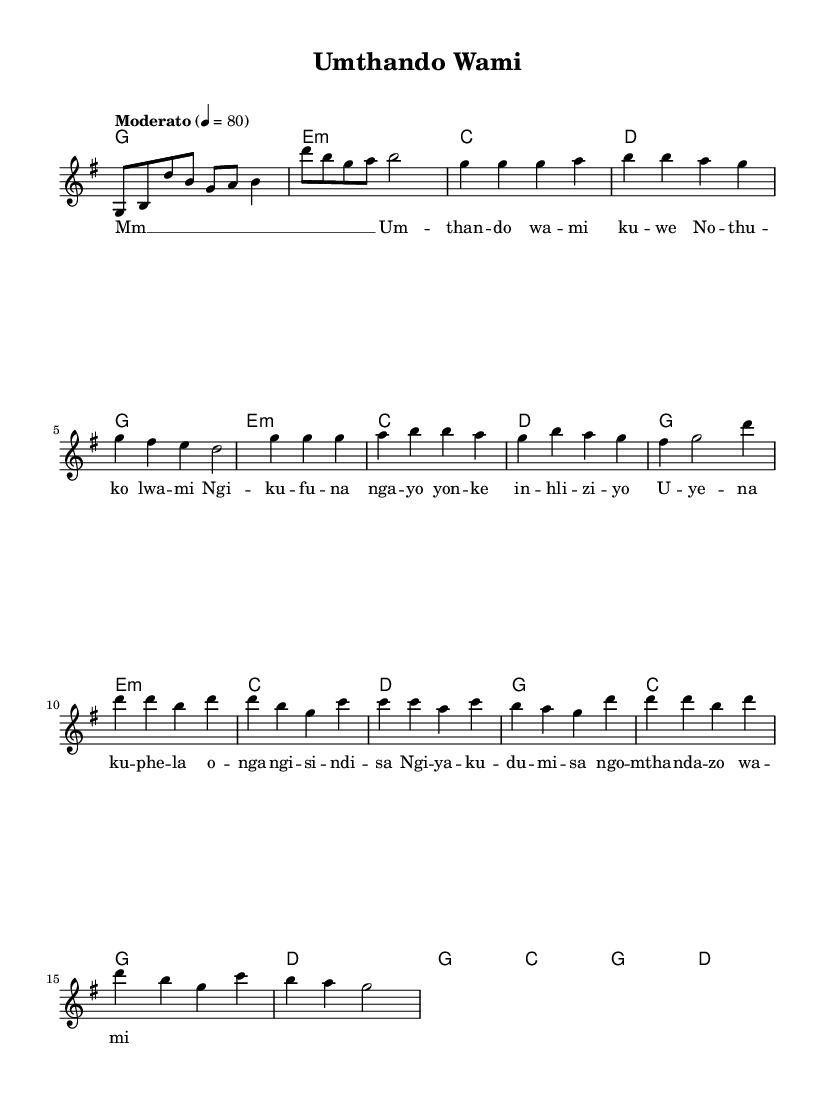What is the key signature of this music? The key signature is G major, which has one sharp (F#). This can be determined from the global settings where the key is indicated as 'g' in the \key command.
Answer: G major What is the time signature of this piece? The time signature is 4/4, which can be found in the global settings under the \time command. It indicates that there are four beats in each measure.
Answer: 4/4 What is the tempo marking for this music? The tempo marking is "Moderato," which is indicated in the global settings. It typically indicates a moderate pace of the music.
Answer: Moderato How many measures are in the verse section? There are eight measures in the verse section. This can be counted from each line of the melody section, noting that each phrase is one measure long.
Answer: Eight What is the first chord in the chorus? The first chord in the chorus is G major. Chord progressions can be observed in the harmonies section where the chords are listed, and the first chord in the chorus is marked first.
Answer: G major What lyrical theme does the chorus convey? The chorus conveys love and devotion, emphasizing feelings associated with love as expressed through the lyrics. The repetition of "Ngi ya ku du mi sa ngo mtha nda zo wa mi" portrays strong emotional sentiments.
Answer: Love and devotion What type of musical influence does this piece illustrate? This piece illustrates gospel influence, which is evident through its lyrical content, emotional expressivity, and stylistic elements often found in gospel music. The themes and melodies reflect traditional gospel styles.
Answer: Gospel influence 